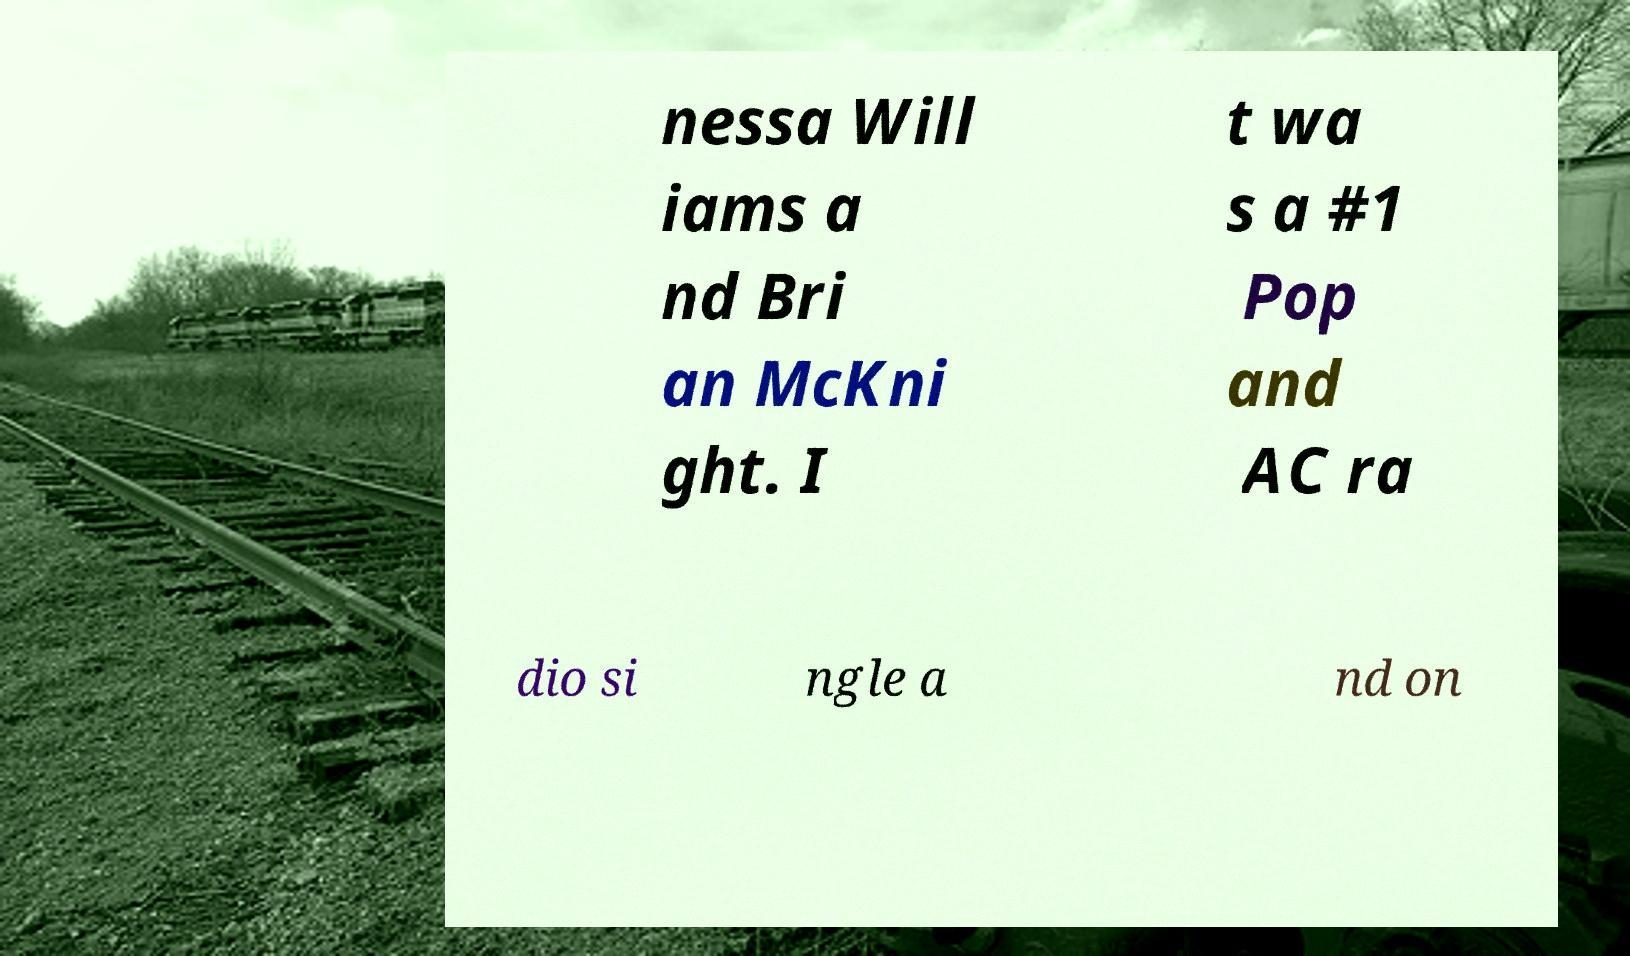I need the written content from this picture converted into text. Can you do that? nessa Will iams a nd Bri an McKni ght. I t wa s a #1 Pop and AC ra dio si ngle a nd on 